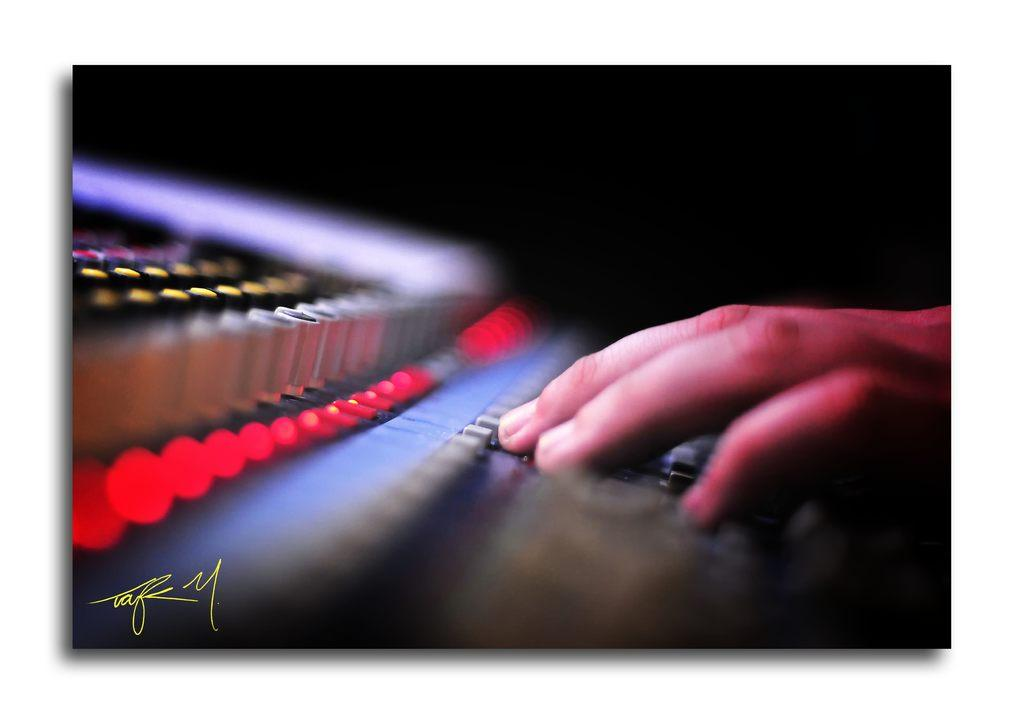What can be seen on the right side of the image? There is a hand of a person on the right side of the image. What is located under the hand in the image? There is an equipment under the hand. Where is the watermark in the image? The watermark is on the bottom left side of the image. Is there any blood visible on the hand in the image? No, there is no blood visible on the hand in the image. What type of quiver is being used by the person in the image? There is no quiver present in the image. 